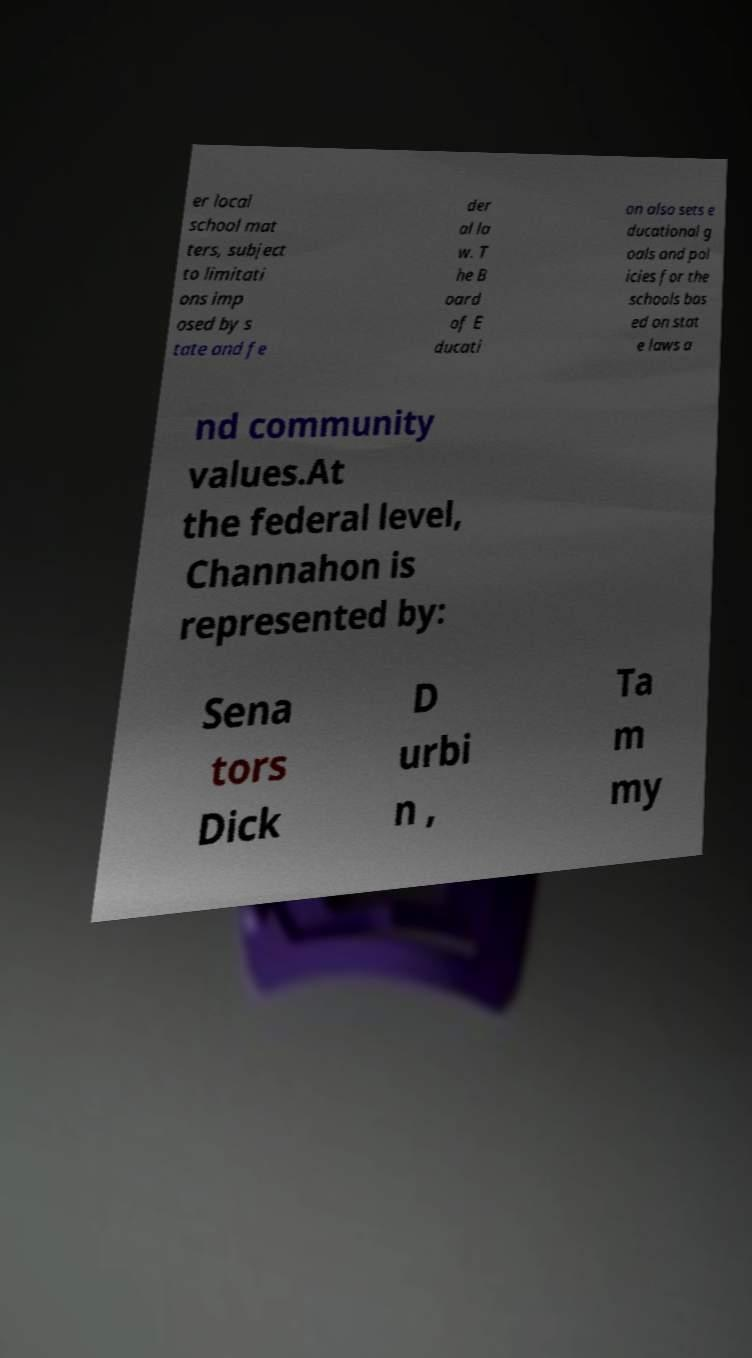Please read and relay the text visible in this image. What does it say? er local school mat ters, subject to limitati ons imp osed by s tate and fe der al la w. T he B oard of E ducati on also sets e ducational g oals and pol icies for the schools bas ed on stat e laws a nd community values.At the federal level, Channahon is represented by: Sena tors Dick D urbi n , Ta m my 